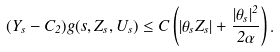<formula> <loc_0><loc_0><loc_500><loc_500>( Y _ { s } - C _ { 2 } ) g ( s , Z _ { s } , U _ { s } ) \leq C \left ( | \theta _ { s } Z _ { s } | + \frac { | \theta _ { s } | ^ { 2 } } { 2 \alpha } \right ) .</formula> 